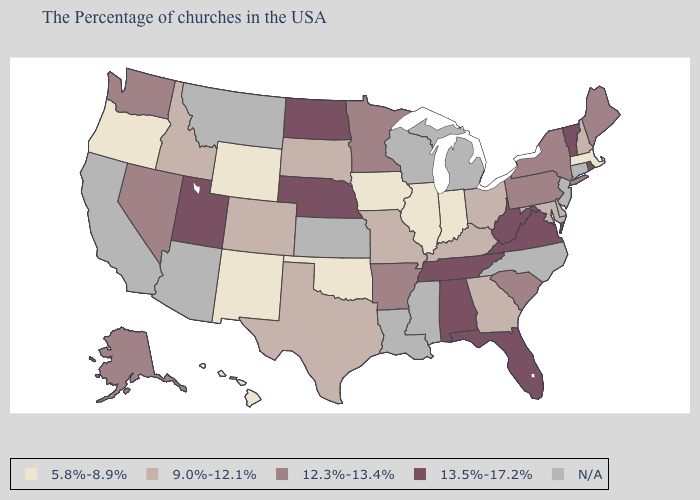Name the states that have a value in the range 5.8%-8.9%?
Quick response, please. Massachusetts, Indiana, Illinois, Iowa, Oklahoma, Wyoming, New Mexico, Oregon, Hawaii. Name the states that have a value in the range 5.8%-8.9%?
Write a very short answer. Massachusetts, Indiana, Illinois, Iowa, Oklahoma, Wyoming, New Mexico, Oregon, Hawaii. How many symbols are there in the legend?
Write a very short answer. 5. What is the highest value in the South ?
Answer briefly. 13.5%-17.2%. What is the value of Texas?
Be succinct. 9.0%-12.1%. Name the states that have a value in the range 9.0%-12.1%?
Give a very brief answer. New Hampshire, Maryland, Ohio, Georgia, Kentucky, Missouri, Texas, South Dakota, Colorado, Idaho. Which states have the highest value in the USA?
Answer briefly. Rhode Island, Vermont, Virginia, West Virginia, Florida, Alabama, Tennessee, Nebraska, North Dakota, Utah. Name the states that have a value in the range N/A?
Answer briefly. Connecticut, New Jersey, Delaware, North Carolina, Michigan, Wisconsin, Mississippi, Louisiana, Kansas, Montana, Arizona, California. Does Hawaii have the lowest value in the USA?
Quick response, please. Yes. What is the lowest value in the USA?
Concise answer only. 5.8%-8.9%. Name the states that have a value in the range N/A?
Short answer required. Connecticut, New Jersey, Delaware, North Carolina, Michigan, Wisconsin, Mississippi, Louisiana, Kansas, Montana, Arizona, California. What is the value of Rhode Island?
Keep it brief. 13.5%-17.2%. Which states hav the highest value in the Northeast?
Give a very brief answer. Rhode Island, Vermont. 